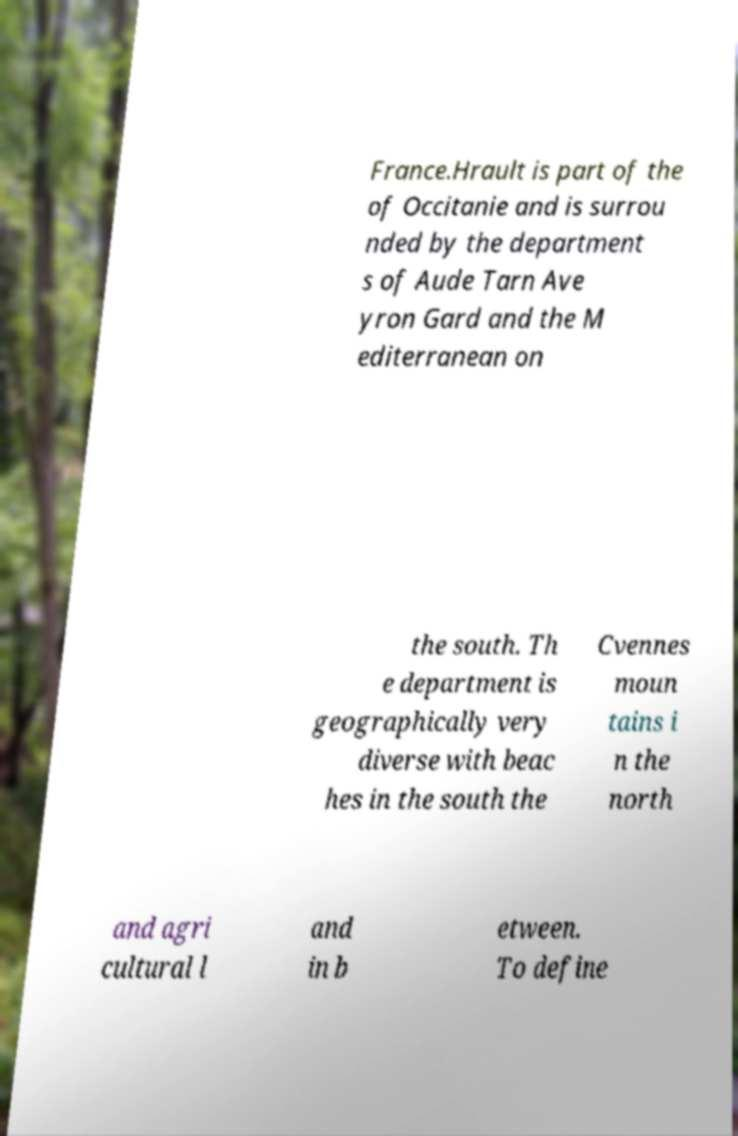Could you extract and type out the text from this image? France.Hrault is part of the of Occitanie and is surrou nded by the department s of Aude Tarn Ave yron Gard and the M editerranean on the south. Th e department is geographically very diverse with beac hes in the south the Cvennes moun tains i n the north and agri cultural l and in b etween. To define 